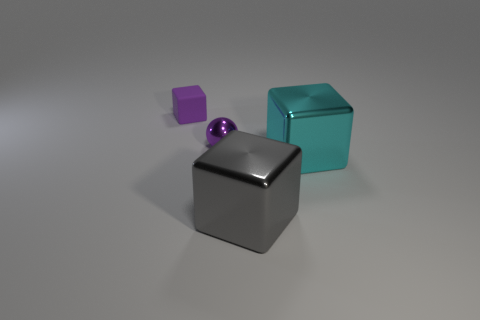There is a rubber block that is the same color as the metal ball; what size is it?
Provide a short and direct response. Small. Are there any other things that are the same size as the gray metallic object?
Offer a very short reply. Yes. The tiny thing to the right of the tiny cube that is to the left of the big thing that is behind the gray metal cube is what color?
Keep it short and to the point. Purple. Is the material of the tiny sphere the same as the big cyan thing?
Your answer should be compact. Yes. How many purple objects are either big metallic things or big matte cylinders?
Provide a succinct answer. 0. There is a small ball; how many small objects are in front of it?
Your answer should be compact. 0. Are there more big cyan metallic things than large blue shiny things?
Keep it short and to the point. Yes. The shiny thing that is left of the large thing in front of the cyan thing is what shape?
Ensure brevity in your answer.  Sphere. Is the color of the tiny cube the same as the tiny shiny ball?
Make the answer very short. Yes. Are there more metallic things that are right of the small purple metallic object than red metallic things?
Your answer should be very brief. Yes. 